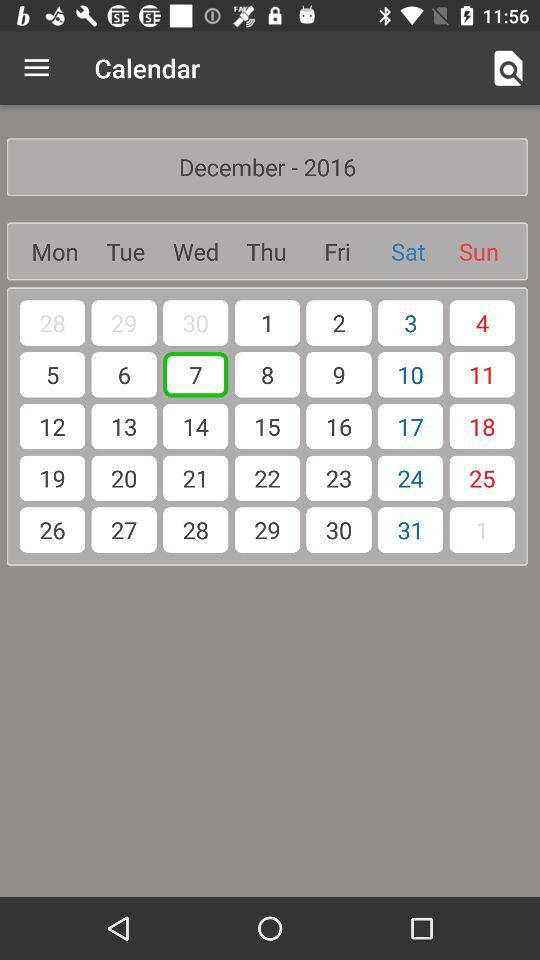What is the application name? The application name is "Calendar". 